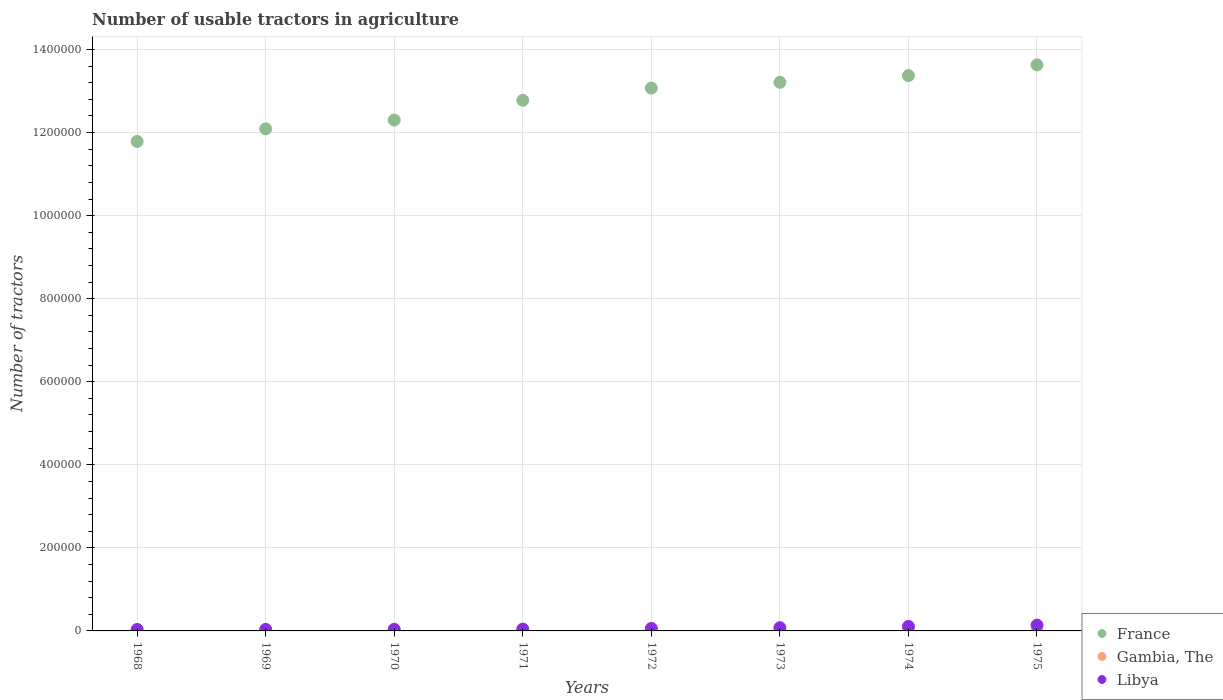How many different coloured dotlines are there?
Ensure brevity in your answer.  3. Is the number of dotlines equal to the number of legend labels?
Your answer should be compact. Yes. What is the number of usable tractors in agriculture in Libya in 1974?
Keep it short and to the point. 1.09e+04. Across all years, what is the maximum number of usable tractors in agriculture in Libya?
Give a very brief answer. 1.40e+04. Across all years, what is the minimum number of usable tractors in agriculture in France?
Make the answer very short. 1.18e+06. In which year was the number of usable tractors in agriculture in Gambia, The maximum?
Give a very brief answer. 1974. In which year was the number of usable tractors in agriculture in Libya minimum?
Your response must be concise. 1968. What is the total number of usable tractors in agriculture in Gambia, The in the graph?
Your response must be concise. 360. What is the difference between the number of usable tractors in agriculture in Libya in 1969 and that in 1970?
Your response must be concise. -150. What is the difference between the number of usable tractors in agriculture in France in 1968 and the number of usable tractors in agriculture in Gambia, The in 1970?
Make the answer very short. 1.18e+06. What is the average number of usable tractors in agriculture in Gambia, The per year?
Ensure brevity in your answer.  45. In the year 1968, what is the difference between the number of usable tractors in agriculture in France and number of usable tractors in agriculture in Gambia, The?
Offer a terse response. 1.18e+06. In how many years, is the number of usable tractors in agriculture in Libya greater than 560000?
Ensure brevity in your answer.  0. What is the ratio of the number of usable tractors in agriculture in France in 1972 to that in 1975?
Make the answer very short. 0.96. Is the difference between the number of usable tractors in agriculture in France in 1971 and 1972 greater than the difference between the number of usable tractors in agriculture in Gambia, The in 1971 and 1972?
Give a very brief answer. No. What is the difference between the highest and the second highest number of usable tractors in agriculture in France?
Your answer should be compact. 2.59e+04. What is the difference between the highest and the lowest number of usable tractors in agriculture in France?
Ensure brevity in your answer.  1.84e+05. Is the sum of the number of usable tractors in agriculture in Gambia, The in 1968 and 1974 greater than the maximum number of usable tractors in agriculture in France across all years?
Offer a very short reply. No. Is it the case that in every year, the sum of the number of usable tractors in agriculture in France and number of usable tractors in agriculture in Libya  is greater than the number of usable tractors in agriculture in Gambia, The?
Make the answer very short. Yes. Is the number of usable tractors in agriculture in Gambia, The strictly less than the number of usable tractors in agriculture in Libya over the years?
Your response must be concise. Yes. How many dotlines are there?
Provide a short and direct response. 3. How many years are there in the graph?
Offer a very short reply. 8. What is the difference between two consecutive major ticks on the Y-axis?
Your response must be concise. 2.00e+05. Are the values on the major ticks of Y-axis written in scientific E-notation?
Ensure brevity in your answer.  No. Does the graph contain any zero values?
Make the answer very short. No. Where does the legend appear in the graph?
Your response must be concise. Bottom right. How many legend labels are there?
Your answer should be compact. 3. How are the legend labels stacked?
Provide a short and direct response. Vertical. What is the title of the graph?
Your answer should be very brief. Number of usable tractors in agriculture. Does "Lebanon" appear as one of the legend labels in the graph?
Your answer should be very brief. No. What is the label or title of the Y-axis?
Offer a very short reply. Number of tractors. What is the Number of tractors of France in 1968?
Offer a very short reply. 1.18e+06. What is the Number of tractors in Libya in 1968?
Your answer should be very brief. 3500. What is the Number of tractors in France in 1969?
Ensure brevity in your answer.  1.21e+06. What is the Number of tractors of Gambia, The in 1969?
Your answer should be compact. 44. What is the Number of tractors of Libya in 1969?
Give a very brief answer. 3700. What is the Number of tractors of France in 1970?
Make the answer very short. 1.23e+06. What is the Number of tractors in Libya in 1970?
Offer a very short reply. 3850. What is the Number of tractors in France in 1971?
Your answer should be very brief. 1.28e+06. What is the Number of tractors of Libya in 1971?
Make the answer very short. 4400. What is the Number of tractors of France in 1972?
Keep it short and to the point. 1.31e+06. What is the Number of tractors of Gambia, The in 1972?
Offer a very short reply. 45. What is the Number of tractors in Libya in 1972?
Keep it short and to the point. 6000. What is the Number of tractors in France in 1973?
Offer a very short reply. 1.32e+06. What is the Number of tractors in Libya in 1973?
Your response must be concise. 7800. What is the Number of tractors of France in 1974?
Provide a succinct answer. 1.34e+06. What is the Number of tractors of Gambia, The in 1974?
Give a very brief answer. 46. What is the Number of tractors in Libya in 1974?
Your answer should be compact. 1.09e+04. What is the Number of tractors of France in 1975?
Keep it short and to the point. 1.36e+06. What is the Number of tractors of Gambia, The in 1975?
Provide a succinct answer. 46. What is the Number of tractors of Libya in 1975?
Provide a short and direct response. 1.40e+04. Across all years, what is the maximum Number of tractors of France?
Make the answer very short. 1.36e+06. Across all years, what is the maximum Number of tractors of Libya?
Offer a terse response. 1.40e+04. Across all years, what is the minimum Number of tractors of France?
Give a very brief answer. 1.18e+06. Across all years, what is the minimum Number of tractors of Libya?
Your response must be concise. 3500. What is the total Number of tractors in France in the graph?
Keep it short and to the point. 1.02e+07. What is the total Number of tractors of Gambia, The in the graph?
Provide a succinct answer. 360. What is the total Number of tractors in Libya in the graph?
Your response must be concise. 5.42e+04. What is the difference between the Number of tractors of France in 1968 and that in 1969?
Provide a short and direct response. -3.04e+04. What is the difference between the Number of tractors of Libya in 1968 and that in 1969?
Keep it short and to the point. -200. What is the difference between the Number of tractors of France in 1968 and that in 1970?
Your answer should be compact. -5.15e+04. What is the difference between the Number of tractors in Libya in 1968 and that in 1970?
Offer a very short reply. -350. What is the difference between the Number of tractors of France in 1968 and that in 1971?
Make the answer very short. -9.91e+04. What is the difference between the Number of tractors in Gambia, The in 1968 and that in 1971?
Provide a succinct answer. -1. What is the difference between the Number of tractors of Libya in 1968 and that in 1971?
Ensure brevity in your answer.  -900. What is the difference between the Number of tractors in France in 1968 and that in 1972?
Provide a short and direct response. -1.28e+05. What is the difference between the Number of tractors of Libya in 1968 and that in 1972?
Ensure brevity in your answer.  -2500. What is the difference between the Number of tractors of France in 1968 and that in 1973?
Your answer should be compact. -1.42e+05. What is the difference between the Number of tractors of Libya in 1968 and that in 1973?
Provide a short and direct response. -4300. What is the difference between the Number of tractors of France in 1968 and that in 1974?
Provide a succinct answer. -1.59e+05. What is the difference between the Number of tractors in Gambia, The in 1968 and that in 1974?
Ensure brevity in your answer.  -2. What is the difference between the Number of tractors in Libya in 1968 and that in 1974?
Offer a very short reply. -7400. What is the difference between the Number of tractors in France in 1968 and that in 1975?
Your answer should be very brief. -1.84e+05. What is the difference between the Number of tractors in Gambia, The in 1968 and that in 1975?
Make the answer very short. -2. What is the difference between the Number of tractors of Libya in 1968 and that in 1975?
Ensure brevity in your answer.  -1.05e+04. What is the difference between the Number of tractors in France in 1969 and that in 1970?
Offer a very short reply. -2.12e+04. What is the difference between the Number of tractors in Gambia, The in 1969 and that in 1970?
Provide a short and direct response. -1. What is the difference between the Number of tractors in Libya in 1969 and that in 1970?
Your response must be concise. -150. What is the difference between the Number of tractors of France in 1969 and that in 1971?
Your answer should be compact. -6.88e+04. What is the difference between the Number of tractors in Gambia, The in 1969 and that in 1971?
Your answer should be very brief. -1. What is the difference between the Number of tractors of Libya in 1969 and that in 1971?
Your answer should be compact. -700. What is the difference between the Number of tractors of France in 1969 and that in 1972?
Make the answer very short. -9.81e+04. What is the difference between the Number of tractors of Libya in 1969 and that in 1972?
Keep it short and to the point. -2300. What is the difference between the Number of tractors in France in 1969 and that in 1973?
Offer a terse response. -1.12e+05. What is the difference between the Number of tractors in Libya in 1969 and that in 1973?
Your response must be concise. -4100. What is the difference between the Number of tractors of France in 1969 and that in 1974?
Your response must be concise. -1.28e+05. What is the difference between the Number of tractors of Gambia, The in 1969 and that in 1974?
Your response must be concise. -2. What is the difference between the Number of tractors of Libya in 1969 and that in 1974?
Your response must be concise. -7200. What is the difference between the Number of tractors in France in 1969 and that in 1975?
Ensure brevity in your answer.  -1.54e+05. What is the difference between the Number of tractors in Gambia, The in 1969 and that in 1975?
Ensure brevity in your answer.  -2. What is the difference between the Number of tractors of Libya in 1969 and that in 1975?
Give a very brief answer. -1.03e+04. What is the difference between the Number of tractors in France in 1970 and that in 1971?
Give a very brief answer. -4.76e+04. What is the difference between the Number of tractors of Gambia, The in 1970 and that in 1971?
Offer a very short reply. 0. What is the difference between the Number of tractors in Libya in 1970 and that in 1971?
Ensure brevity in your answer.  -550. What is the difference between the Number of tractors of France in 1970 and that in 1972?
Your answer should be compact. -7.69e+04. What is the difference between the Number of tractors of Gambia, The in 1970 and that in 1972?
Give a very brief answer. 0. What is the difference between the Number of tractors in Libya in 1970 and that in 1972?
Give a very brief answer. -2150. What is the difference between the Number of tractors of France in 1970 and that in 1973?
Ensure brevity in your answer.  -9.08e+04. What is the difference between the Number of tractors of Libya in 1970 and that in 1973?
Keep it short and to the point. -3950. What is the difference between the Number of tractors of France in 1970 and that in 1974?
Offer a very short reply. -1.07e+05. What is the difference between the Number of tractors of Gambia, The in 1970 and that in 1974?
Give a very brief answer. -1. What is the difference between the Number of tractors in Libya in 1970 and that in 1974?
Provide a short and direct response. -7050. What is the difference between the Number of tractors of France in 1970 and that in 1975?
Your answer should be compact. -1.33e+05. What is the difference between the Number of tractors of Libya in 1970 and that in 1975?
Provide a succinct answer. -1.02e+04. What is the difference between the Number of tractors in France in 1971 and that in 1972?
Your answer should be compact. -2.93e+04. What is the difference between the Number of tractors in Libya in 1971 and that in 1972?
Keep it short and to the point. -1600. What is the difference between the Number of tractors of France in 1971 and that in 1973?
Ensure brevity in your answer.  -4.32e+04. What is the difference between the Number of tractors of Gambia, The in 1971 and that in 1973?
Ensure brevity in your answer.  0. What is the difference between the Number of tractors of Libya in 1971 and that in 1973?
Provide a short and direct response. -3400. What is the difference between the Number of tractors of France in 1971 and that in 1974?
Make the answer very short. -5.94e+04. What is the difference between the Number of tractors of Libya in 1971 and that in 1974?
Offer a terse response. -6500. What is the difference between the Number of tractors in France in 1971 and that in 1975?
Offer a very short reply. -8.53e+04. What is the difference between the Number of tractors of Libya in 1971 and that in 1975?
Offer a terse response. -9600. What is the difference between the Number of tractors of France in 1972 and that in 1973?
Offer a very short reply. -1.39e+04. What is the difference between the Number of tractors of Gambia, The in 1972 and that in 1973?
Provide a succinct answer. 0. What is the difference between the Number of tractors in Libya in 1972 and that in 1973?
Provide a short and direct response. -1800. What is the difference between the Number of tractors of France in 1972 and that in 1974?
Keep it short and to the point. -3.01e+04. What is the difference between the Number of tractors in Gambia, The in 1972 and that in 1974?
Make the answer very short. -1. What is the difference between the Number of tractors of Libya in 1972 and that in 1974?
Your answer should be compact. -4900. What is the difference between the Number of tractors of France in 1972 and that in 1975?
Your answer should be compact. -5.60e+04. What is the difference between the Number of tractors of Libya in 1972 and that in 1975?
Make the answer very short. -8000. What is the difference between the Number of tractors in France in 1973 and that in 1974?
Give a very brief answer. -1.62e+04. What is the difference between the Number of tractors of Libya in 1973 and that in 1974?
Provide a short and direct response. -3100. What is the difference between the Number of tractors of France in 1973 and that in 1975?
Make the answer very short. -4.21e+04. What is the difference between the Number of tractors in Libya in 1973 and that in 1975?
Make the answer very short. -6200. What is the difference between the Number of tractors in France in 1974 and that in 1975?
Your response must be concise. -2.59e+04. What is the difference between the Number of tractors in Libya in 1974 and that in 1975?
Provide a succinct answer. -3100. What is the difference between the Number of tractors of France in 1968 and the Number of tractors of Gambia, The in 1969?
Give a very brief answer. 1.18e+06. What is the difference between the Number of tractors of France in 1968 and the Number of tractors of Libya in 1969?
Provide a short and direct response. 1.17e+06. What is the difference between the Number of tractors in Gambia, The in 1968 and the Number of tractors in Libya in 1969?
Provide a short and direct response. -3656. What is the difference between the Number of tractors in France in 1968 and the Number of tractors in Gambia, The in 1970?
Keep it short and to the point. 1.18e+06. What is the difference between the Number of tractors of France in 1968 and the Number of tractors of Libya in 1970?
Your answer should be very brief. 1.17e+06. What is the difference between the Number of tractors in Gambia, The in 1968 and the Number of tractors in Libya in 1970?
Your answer should be compact. -3806. What is the difference between the Number of tractors in France in 1968 and the Number of tractors in Gambia, The in 1971?
Ensure brevity in your answer.  1.18e+06. What is the difference between the Number of tractors of France in 1968 and the Number of tractors of Libya in 1971?
Make the answer very short. 1.17e+06. What is the difference between the Number of tractors in Gambia, The in 1968 and the Number of tractors in Libya in 1971?
Your answer should be compact. -4356. What is the difference between the Number of tractors of France in 1968 and the Number of tractors of Gambia, The in 1972?
Your answer should be compact. 1.18e+06. What is the difference between the Number of tractors of France in 1968 and the Number of tractors of Libya in 1972?
Your answer should be compact. 1.17e+06. What is the difference between the Number of tractors in Gambia, The in 1968 and the Number of tractors in Libya in 1972?
Ensure brevity in your answer.  -5956. What is the difference between the Number of tractors of France in 1968 and the Number of tractors of Gambia, The in 1973?
Make the answer very short. 1.18e+06. What is the difference between the Number of tractors of France in 1968 and the Number of tractors of Libya in 1973?
Provide a short and direct response. 1.17e+06. What is the difference between the Number of tractors of Gambia, The in 1968 and the Number of tractors of Libya in 1973?
Offer a terse response. -7756. What is the difference between the Number of tractors of France in 1968 and the Number of tractors of Gambia, The in 1974?
Keep it short and to the point. 1.18e+06. What is the difference between the Number of tractors of France in 1968 and the Number of tractors of Libya in 1974?
Offer a very short reply. 1.17e+06. What is the difference between the Number of tractors in Gambia, The in 1968 and the Number of tractors in Libya in 1974?
Ensure brevity in your answer.  -1.09e+04. What is the difference between the Number of tractors of France in 1968 and the Number of tractors of Gambia, The in 1975?
Make the answer very short. 1.18e+06. What is the difference between the Number of tractors of France in 1968 and the Number of tractors of Libya in 1975?
Keep it short and to the point. 1.16e+06. What is the difference between the Number of tractors in Gambia, The in 1968 and the Number of tractors in Libya in 1975?
Provide a short and direct response. -1.40e+04. What is the difference between the Number of tractors of France in 1969 and the Number of tractors of Gambia, The in 1970?
Your answer should be compact. 1.21e+06. What is the difference between the Number of tractors of France in 1969 and the Number of tractors of Libya in 1970?
Provide a short and direct response. 1.21e+06. What is the difference between the Number of tractors in Gambia, The in 1969 and the Number of tractors in Libya in 1970?
Provide a succinct answer. -3806. What is the difference between the Number of tractors in France in 1969 and the Number of tractors in Gambia, The in 1971?
Make the answer very short. 1.21e+06. What is the difference between the Number of tractors in France in 1969 and the Number of tractors in Libya in 1971?
Your answer should be compact. 1.20e+06. What is the difference between the Number of tractors of Gambia, The in 1969 and the Number of tractors of Libya in 1971?
Provide a short and direct response. -4356. What is the difference between the Number of tractors of France in 1969 and the Number of tractors of Gambia, The in 1972?
Give a very brief answer. 1.21e+06. What is the difference between the Number of tractors of France in 1969 and the Number of tractors of Libya in 1972?
Offer a very short reply. 1.20e+06. What is the difference between the Number of tractors of Gambia, The in 1969 and the Number of tractors of Libya in 1972?
Your response must be concise. -5956. What is the difference between the Number of tractors in France in 1969 and the Number of tractors in Gambia, The in 1973?
Give a very brief answer. 1.21e+06. What is the difference between the Number of tractors of France in 1969 and the Number of tractors of Libya in 1973?
Offer a very short reply. 1.20e+06. What is the difference between the Number of tractors in Gambia, The in 1969 and the Number of tractors in Libya in 1973?
Make the answer very short. -7756. What is the difference between the Number of tractors of France in 1969 and the Number of tractors of Gambia, The in 1974?
Offer a very short reply. 1.21e+06. What is the difference between the Number of tractors in France in 1969 and the Number of tractors in Libya in 1974?
Keep it short and to the point. 1.20e+06. What is the difference between the Number of tractors of Gambia, The in 1969 and the Number of tractors of Libya in 1974?
Ensure brevity in your answer.  -1.09e+04. What is the difference between the Number of tractors in France in 1969 and the Number of tractors in Gambia, The in 1975?
Keep it short and to the point. 1.21e+06. What is the difference between the Number of tractors of France in 1969 and the Number of tractors of Libya in 1975?
Ensure brevity in your answer.  1.20e+06. What is the difference between the Number of tractors of Gambia, The in 1969 and the Number of tractors of Libya in 1975?
Your answer should be very brief. -1.40e+04. What is the difference between the Number of tractors of France in 1970 and the Number of tractors of Gambia, The in 1971?
Your answer should be compact. 1.23e+06. What is the difference between the Number of tractors in France in 1970 and the Number of tractors in Libya in 1971?
Give a very brief answer. 1.23e+06. What is the difference between the Number of tractors of Gambia, The in 1970 and the Number of tractors of Libya in 1971?
Your answer should be compact. -4355. What is the difference between the Number of tractors of France in 1970 and the Number of tractors of Gambia, The in 1972?
Offer a terse response. 1.23e+06. What is the difference between the Number of tractors of France in 1970 and the Number of tractors of Libya in 1972?
Provide a succinct answer. 1.22e+06. What is the difference between the Number of tractors in Gambia, The in 1970 and the Number of tractors in Libya in 1972?
Ensure brevity in your answer.  -5955. What is the difference between the Number of tractors of France in 1970 and the Number of tractors of Gambia, The in 1973?
Offer a very short reply. 1.23e+06. What is the difference between the Number of tractors in France in 1970 and the Number of tractors in Libya in 1973?
Ensure brevity in your answer.  1.22e+06. What is the difference between the Number of tractors in Gambia, The in 1970 and the Number of tractors in Libya in 1973?
Your answer should be very brief. -7755. What is the difference between the Number of tractors in France in 1970 and the Number of tractors in Gambia, The in 1974?
Your answer should be compact. 1.23e+06. What is the difference between the Number of tractors of France in 1970 and the Number of tractors of Libya in 1974?
Your response must be concise. 1.22e+06. What is the difference between the Number of tractors of Gambia, The in 1970 and the Number of tractors of Libya in 1974?
Provide a short and direct response. -1.09e+04. What is the difference between the Number of tractors in France in 1970 and the Number of tractors in Gambia, The in 1975?
Your response must be concise. 1.23e+06. What is the difference between the Number of tractors in France in 1970 and the Number of tractors in Libya in 1975?
Your answer should be very brief. 1.22e+06. What is the difference between the Number of tractors of Gambia, The in 1970 and the Number of tractors of Libya in 1975?
Offer a terse response. -1.40e+04. What is the difference between the Number of tractors in France in 1971 and the Number of tractors in Gambia, The in 1972?
Make the answer very short. 1.28e+06. What is the difference between the Number of tractors of France in 1971 and the Number of tractors of Libya in 1972?
Provide a short and direct response. 1.27e+06. What is the difference between the Number of tractors of Gambia, The in 1971 and the Number of tractors of Libya in 1972?
Provide a succinct answer. -5955. What is the difference between the Number of tractors of France in 1971 and the Number of tractors of Gambia, The in 1973?
Provide a short and direct response. 1.28e+06. What is the difference between the Number of tractors of France in 1971 and the Number of tractors of Libya in 1973?
Provide a succinct answer. 1.27e+06. What is the difference between the Number of tractors of Gambia, The in 1971 and the Number of tractors of Libya in 1973?
Your answer should be compact. -7755. What is the difference between the Number of tractors of France in 1971 and the Number of tractors of Gambia, The in 1974?
Keep it short and to the point. 1.28e+06. What is the difference between the Number of tractors in France in 1971 and the Number of tractors in Libya in 1974?
Offer a very short reply. 1.27e+06. What is the difference between the Number of tractors of Gambia, The in 1971 and the Number of tractors of Libya in 1974?
Offer a terse response. -1.09e+04. What is the difference between the Number of tractors of France in 1971 and the Number of tractors of Gambia, The in 1975?
Provide a short and direct response. 1.28e+06. What is the difference between the Number of tractors in France in 1971 and the Number of tractors in Libya in 1975?
Your answer should be compact. 1.26e+06. What is the difference between the Number of tractors in Gambia, The in 1971 and the Number of tractors in Libya in 1975?
Make the answer very short. -1.40e+04. What is the difference between the Number of tractors of France in 1972 and the Number of tractors of Gambia, The in 1973?
Provide a succinct answer. 1.31e+06. What is the difference between the Number of tractors of France in 1972 and the Number of tractors of Libya in 1973?
Offer a very short reply. 1.30e+06. What is the difference between the Number of tractors in Gambia, The in 1972 and the Number of tractors in Libya in 1973?
Offer a terse response. -7755. What is the difference between the Number of tractors in France in 1972 and the Number of tractors in Gambia, The in 1974?
Your answer should be compact. 1.31e+06. What is the difference between the Number of tractors of France in 1972 and the Number of tractors of Libya in 1974?
Keep it short and to the point. 1.30e+06. What is the difference between the Number of tractors of Gambia, The in 1972 and the Number of tractors of Libya in 1974?
Offer a very short reply. -1.09e+04. What is the difference between the Number of tractors in France in 1972 and the Number of tractors in Gambia, The in 1975?
Offer a terse response. 1.31e+06. What is the difference between the Number of tractors in France in 1972 and the Number of tractors in Libya in 1975?
Provide a succinct answer. 1.29e+06. What is the difference between the Number of tractors of Gambia, The in 1972 and the Number of tractors of Libya in 1975?
Give a very brief answer. -1.40e+04. What is the difference between the Number of tractors in France in 1973 and the Number of tractors in Gambia, The in 1974?
Provide a short and direct response. 1.32e+06. What is the difference between the Number of tractors in France in 1973 and the Number of tractors in Libya in 1974?
Your answer should be very brief. 1.31e+06. What is the difference between the Number of tractors of Gambia, The in 1973 and the Number of tractors of Libya in 1974?
Ensure brevity in your answer.  -1.09e+04. What is the difference between the Number of tractors of France in 1973 and the Number of tractors of Gambia, The in 1975?
Your response must be concise. 1.32e+06. What is the difference between the Number of tractors of France in 1973 and the Number of tractors of Libya in 1975?
Provide a short and direct response. 1.31e+06. What is the difference between the Number of tractors in Gambia, The in 1973 and the Number of tractors in Libya in 1975?
Ensure brevity in your answer.  -1.40e+04. What is the difference between the Number of tractors of France in 1974 and the Number of tractors of Gambia, The in 1975?
Your response must be concise. 1.34e+06. What is the difference between the Number of tractors in France in 1974 and the Number of tractors in Libya in 1975?
Provide a short and direct response. 1.32e+06. What is the difference between the Number of tractors in Gambia, The in 1974 and the Number of tractors in Libya in 1975?
Your answer should be compact. -1.40e+04. What is the average Number of tractors of France per year?
Keep it short and to the point. 1.28e+06. What is the average Number of tractors of Gambia, The per year?
Offer a very short reply. 45. What is the average Number of tractors of Libya per year?
Your response must be concise. 6768.75. In the year 1968, what is the difference between the Number of tractors in France and Number of tractors in Gambia, The?
Provide a short and direct response. 1.18e+06. In the year 1968, what is the difference between the Number of tractors in France and Number of tractors in Libya?
Provide a short and direct response. 1.18e+06. In the year 1968, what is the difference between the Number of tractors in Gambia, The and Number of tractors in Libya?
Offer a very short reply. -3456. In the year 1969, what is the difference between the Number of tractors in France and Number of tractors in Gambia, The?
Your answer should be compact. 1.21e+06. In the year 1969, what is the difference between the Number of tractors in France and Number of tractors in Libya?
Keep it short and to the point. 1.21e+06. In the year 1969, what is the difference between the Number of tractors in Gambia, The and Number of tractors in Libya?
Offer a terse response. -3656. In the year 1970, what is the difference between the Number of tractors of France and Number of tractors of Gambia, The?
Give a very brief answer. 1.23e+06. In the year 1970, what is the difference between the Number of tractors in France and Number of tractors in Libya?
Ensure brevity in your answer.  1.23e+06. In the year 1970, what is the difference between the Number of tractors in Gambia, The and Number of tractors in Libya?
Your answer should be very brief. -3805. In the year 1971, what is the difference between the Number of tractors of France and Number of tractors of Gambia, The?
Your response must be concise. 1.28e+06. In the year 1971, what is the difference between the Number of tractors in France and Number of tractors in Libya?
Your response must be concise. 1.27e+06. In the year 1971, what is the difference between the Number of tractors of Gambia, The and Number of tractors of Libya?
Keep it short and to the point. -4355. In the year 1972, what is the difference between the Number of tractors in France and Number of tractors in Gambia, The?
Ensure brevity in your answer.  1.31e+06. In the year 1972, what is the difference between the Number of tractors in France and Number of tractors in Libya?
Your response must be concise. 1.30e+06. In the year 1972, what is the difference between the Number of tractors of Gambia, The and Number of tractors of Libya?
Offer a terse response. -5955. In the year 1973, what is the difference between the Number of tractors in France and Number of tractors in Gambia, The?
Offer a very short reply. 1.32e+06. In the year 1973, what is the difference between the Number of tractors of France and Number of tractors of Libya?
Keep it short and to the point. 1.31e+06. In the year 1973, what is the difference between the Number of tractors in Gambia, The and Number of tractors in Libya?
Ensure brevity in your answer.  -7755. In the year 1974, what is the difference between the Number of tractors of France and Number of tractors of Gambia, The?
Make the answer very short. 1.34e+06. In the year 1974, what is the difference between the Number of tractors in France and Number of tractors in Libya?
Your answer should be compact. 1.33e+06. In the year 1974, what is the difference between the Number of tractors in Gambia, The and Number of tractors in Libya?
Make the answer very short. -1.09e+04. In the year 1975, what is the difference between the Number of tractors of France and Number of tractors of Gambia, The?
Give a very brief answer. 1.36e+06. In the year 1975, what is the difference between the Number of tractors of France and Number of tractors of Libya?
Ensure brevity in your answer.  1.35e+06. In the year 1975, what is the difference between the Number of tractors of Gambia, The and Number of tractors of Libya?
Provide a succinct answer. -1.40e+04. What is the ratio of the Number of tractors of France in 1968 to that in 1969?
Provide a short and direct response. 0.97. What is the ratio of the Number of tractors in Libya in 1968 to that in 1969?
Your answer should be very brief. 0.95. What is the ratio of the Number of tractors in France in 1968 to that in 1970?
Offer a terse response. 0.96. What is the ratio of the Number of tractors of Gambia, The in 1968 to that in 1970?
Ensure brevity in your answer.  0.98. What is the ratio of the Number of tractors of Libya in 1968 to that in 1970?
Your response must be concise. 0.91. What is the ratio of the Number of tractors in France in 1968 to that in 1971?
Offer a very short reply. 0.92. What is the ratio of the Number of tractors in Gambia, The in 1968 to that in 1971?
Offer a terse response. 0.98. What is the ratio of the Number of tractors in Libya in 1968 to that in 1971?
Your answer should be very brief. 0.8. What is the ratio of the Number of tractors of France in 1968 to that in 1972?
Provide a short and direct response. 0.9. What is the ratio of the Number of tractors in Gambia, The in 1968 to that in 1972?
Give a very brief answer. 0.98. What is the ratio of the Number of tractors in Libya in 1968 to that in 1972?
Keep it short and to the point. 0.58. What is the ratio of the Number of tractors in France in 1968 to that in 1973?
Make the answer very short. 0.89. What is the ratio of the Number of tractors in Gambia, The in 1968 to that in 1973?
Give a very brief answer. 0.98. What is the ratio of the Number of tractors of Libya in 1968 to that in 1973?
Offer a very short reply. 0.45. What is the ratio of the Number of tractors of France in 1968 to that in 1974?
Your response must be concise. 0.88. What is the ratio of the Number of tractors of Gambia, The in 1968 to that in 1974?
Provide a succinct answer. 0.96. What is the ratio of the Number of tractors of Libya in 1968 to that in 1974?
Your answer should be very brief. 0.32. What is the ratio of the Number of tractors of France in 1968 to that in 1975?
Keep it short and to the point. 0.86. What is the ratio of the Number of tractors in Gambia, The in 1968 to that in 1975?
Your answer should be very brief. 0.96. What is the ratio of the Number of tractors in France in 1969 to that in 1970?
Give a very brief answer. 0.98. What is the ratio of the Number of tractors in Gambia, The in 1969 to that in 1970?
Make the answer very short. 0.98. What is the ratio of the Number of tractors of France in 1969 to that in 1971?
Offer a very short reply. 0.95. What is the ratio of the Number of tractors of Gambia, The in 1969 to that in 1971?
Provide a succinct answer. 0.98. What is the ratio of the Number of tractors of Libya in 1969 to that in 1971?
Keep it short and to the point. 0.84. What is the ratio of the Number of tractors of France in 1969 to that in 1972?
Your answer should be very brief. 0.93. What is the ratio of the Number of tractors of Gambia, The in 1969 to that in 1972?
Make the answer very short. 0.98. What is the ratio of the Number of tractors of Libya in 1969 to that in 1972?
Ensure brevity in your answer.  0.62. What is the ratio of the Number of tractors in France in 1969 to that in 1973?
Offer a very short reply. 0.92. What is the ratio of the Number of tractors of Gambia, The in 1969 to that in 1973?
Offer a very short reply. 0.98. What is the ratio of the Number of tractors in Libya in 1969 to that in 1973?
Offer a terse response. 0.47. What is the ratio of the Number of tractors of France in 1969 to that in 1974?
Ensure brevity in your answer.  0.9. What is the ratio of the Number of tractors of Gambia, The in 1969 to that in 1974?
Keep it short and to the point. 0.96. What is the ratio of the Number of tractors of Libya in 1969 to that in 1974?
Provide a succinct answer. 0.34. What is the ratio of the Number of tractors of France in 1969 to that in 1975?
Your response must be concise. 0.89. What is the ratio of the Number of tractors in Gambia, The in 1969 to that in 1975?
Make the answer very short. 0.96. What is the ratio of the Number of tractors of Libya in 1969 to that in 1975?
Provide a succinct answer. 0.26. What is the ratio of the Number of tractors of France in 1970 to that in 1971?
Provide a short and direct response. 0.96. What is the ratio of the Number of tractors in Libya in 1970 to that in 1971?
Keep it short and to the point. 0.88. What is the ratio of the Number of tractors of Gambia, The in 1970 to that in 1972?
Provide a short and direct response. 1. What is the ratio of the Number of tractors in Libya in 1970 to that in 1972?
Offer a terse response. 0.64. What is the ratio of the Number of tractors of France in 1970 to that in 1973?
Offer a very short reply. 0.93. What is the ratio of the Number of tractors of Gambia, The in 1970 to that in 1973?
Keep it short and to the point. 1. What is the ratio of the Number of tractors in Libya in 1970 to that in 1973?
Offer a terse response. 0.49. What is the ratio of the Number of tractors of France in 1970 to that in 1974?
Offer a terse response. 0.92. What is the ratio of the Number of tractors of Gambia, The in 1970 to that in 1974?
Provide a succinct answer. 0.98. What is the ratio of the Number of tractors in Libya in 1970 to that in 1974?
Keep it short and to the point. 0.35. What is the ratio of the Number of tractors of France in 1970 to that in 1975?
Your response must be concise. 0.9. What is the ratio of the Number of tractors in Gambia, The in 1970 to that in 1975?
Offer a very short reply. 0.98. What is the ratio of the Number of tractors of Libya in 1970 to that in 1975?
Ensure brevity in your answer.  0.28. What is the ratio of the Number of tractors of France in 1971 to that in 1972?
Offer a terse response. 0.98. What is the ratio of the Number of tractors of Libya in 1971 to that in 1972?
Your answer should be very brief. 0.73. What is the ratio of the Number of tractors in France in 1971 to that in 1973?
Give a very brief answer. 0.97. What is the ratio of the Number of tractors in Libya in 1971 to that in 1973?
Keep it short and to the point. 0.56. What is the ratio of the Number of tractors of France in 1971 to that in 1974?
Provide a short and direct response. 0.96. What is the ratio of the Number of tractors in Gambia, The in 1971 to that in 1974?
Provide a succinct answer. 0.98. What is the ratio of the Number of tractors in Libya in 1971 to that in 1974?
Offer a terse response. 0.4. What is the ratio of the Number of tractors in France in 1971 to that in 1975?
Offer a terse response. 0.94. What is the ratio of the Number of tractors of Gambia, The in 1971 to that in 1975?
Your answer should be very brief. 0.98. What is the ratio of the Number of tractors in Libya in 1971 to that in 1975?
Your answer should be very brief. 0.31. What is the ratio of the Number of tractors in France in 1972 to that in 1973?
Provide a short and direct response. 0.99. What is the ratio of the Number of tractors in Gambia, The in 1972 to that in 1973?
Keep it short and to the point. 1. What is the ratio of the Number of tractors in Libya in 1972 to that in 1973?
Make the answer very short. 0.77. What is the ratio of the Number of tractors in France in 1972 to that in 1974?
Ensure brevity in your answer.  0.98. What is the ratio of the Number of tractors in Gambia, The in 1972 to that in 1974?
Your response must be concise. 0.98. What is the ratio of the Number of tractors in Libya in 1972 to that in 1974?
Provide a succinct answer. 0.55. What is the ratio of the Number of tractors in France in 1972 to that in 1975?
Your response must be concise. 0.96. What is the ratio of the Number of tractors in Gambia, The in 1972 to that in 1975?
Provide a short and direct response. 0.98. What is the ratio of the Number of tractors of Libya in 1972 to that in 1975?
Make the answer very short. 0.43. What is the ratio of the Number of tractors of France in 1973 to that in 1974?
Your answer should be very brief. 0.99. What is the ratio of the Number of tractors of Gambia, The in 1973 to that in 1974?
Your response must be concise. 0.98. What is the ratio of the Number of tractors of Libya in 1973 to that in 1974?
Offer a very short reply. 0.72. What is the ratio of the Number of tractors of France in 1973 to that in 1975?
Ensure brevity in your answer.  0.97. What is the ratio of the Number of tractors of Gambia, The in 1973 to that in 1975?
Your response must be concise. 0.98. What is the ratio of the Number of tractors of Libya in 1973 to that in 1975?
Your answer should be very brief. 0.56. What is the ratio of the Number of tractors in Libya in 1974 to that in 1975?
Offer a terse response. 0.78. What is the difference between the highest and the second highest Number of tractors of France?
Provide a succinct answer. 2.59e+04. What is the difference between the highest and the second highest Number of tractors of Gambia, The?
Make the answer very short. 0. What is the difference between the highest and the second highest Number of tractors in Libya?
Provide a short and direct response. 3100. What is the difference between the highest and the lowest Number of tractors of France?
Give a very brief answer. 1.84e+05. What is the difference between the highest and the lowest Number of tractors of Gambia, The?
Your response must be concise. 2. What is the difference between the highest and the lowest Number of tractors in Libya?
Your response must be concise. 1.05e+04. 